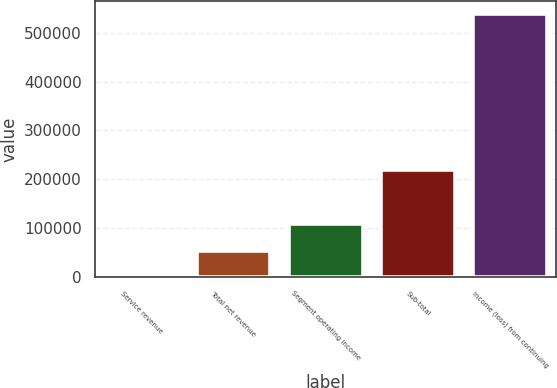<chart> <loc_0><loc_0><loc_500><loc_500><bar_chart><fcel>Service revenue<fcel>Total net revenue<fcel>Segment operating income<fcel>Sub-total<fcel>Income (loss) from continuing<nl><fcel>95<fcel>53909.2<fcel>107723<fcel>218806<fcel>538237<nl></chart> 